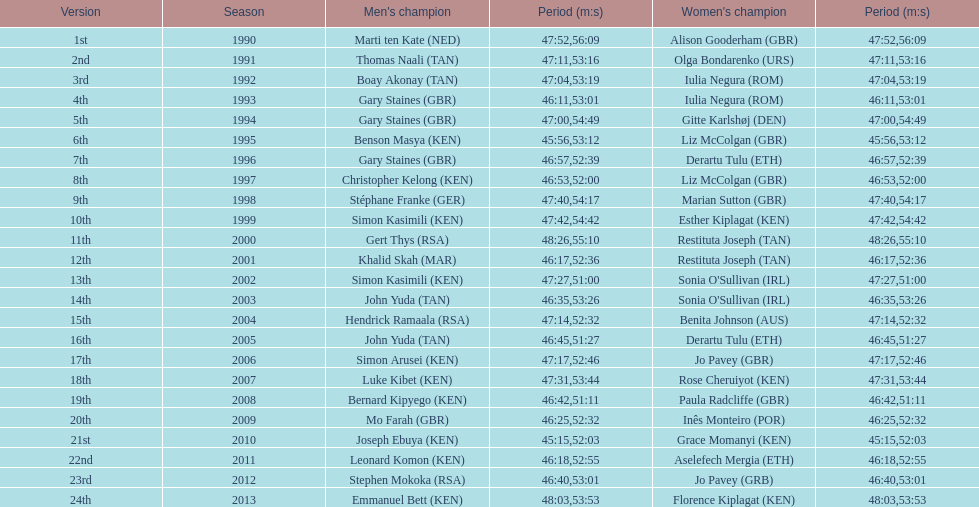Where any women faster than any men? No. 